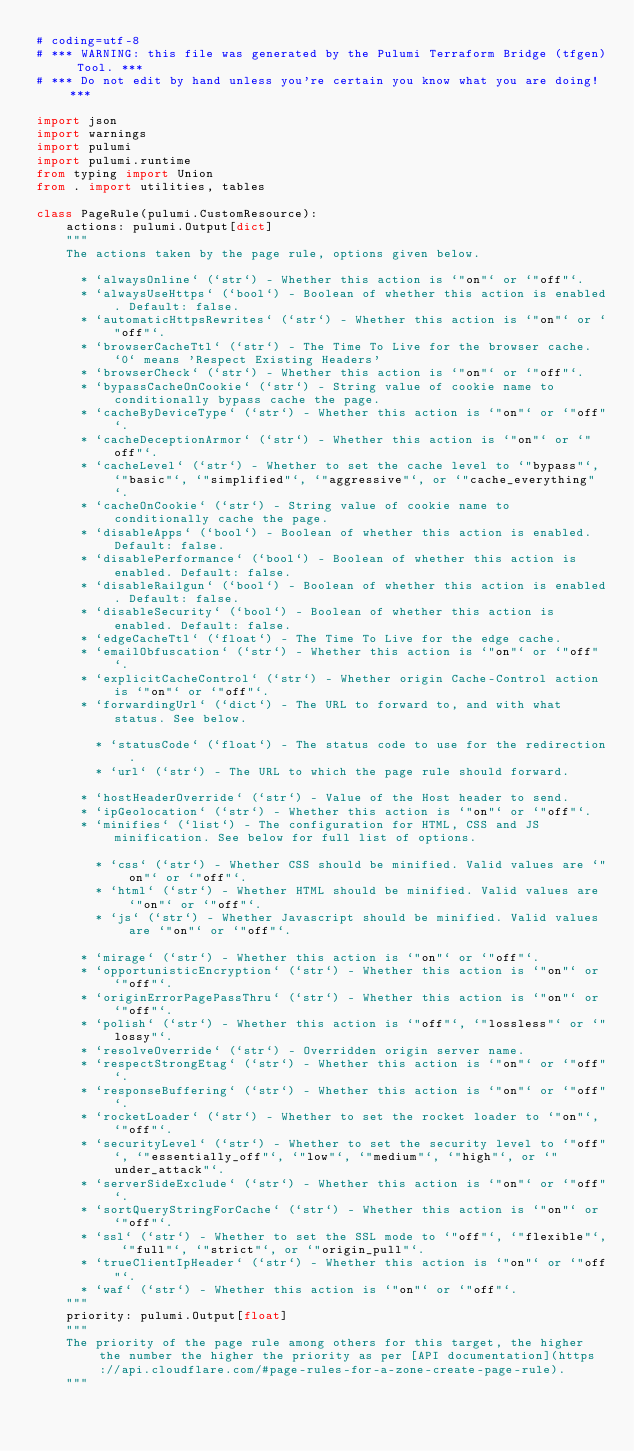<code> <loc_0><loc_0><loc_500><loc_500><_Python_># coding=utf-8
# *** WARNING: this file was generated by the Pulumi Terraform Bridge (tfgen) Tool. ***
# *** Do not edit by hand unless you're certain you know what you are doing! ***

import json
import warnings
import pulumi
import pulumi.runtime
from typing import Union
from . import utilities, tables

class PageRule(pulumi.CustomResource):
    actions: pulumi.Output[dict]
    """
    The actions taken by the page rule, options given below.
    
      * `alwaysOnline` (`str`) - Whether this action is `"on"` or `"off"`.
      * `alwaysUseHttps` (`bool`) - Boolean of whether this action is enabled. Default: false.
      * `automaticHttpsRewrites` (`str`) - Whether this action is `"on"` or `"off"`.
      * `browserCacheTtl` (`str`) - The Time To Live for the browser cache. `0` means 'Respect Existing Headers'
      * `browserCheck` (`str`) - Whether this action is `"on"` or `"off"`.
      * `bypassCacheOnCookie` (`str`) - String value of cookie name to conditionally bypass cache the page.
      * `cacheByDeviceType` (`str`) - Whether this action is `"on"` or `"off"`.
      * `cacheDeceptionArmor` (`str`) - Whether this action is `"on"` or `"off"`.
      * `cacheLevel` (`str`) - Whether to set the cache level to `"bypass"`, `"basic"`, `"simplified"`, `"aggressive"`, or `"cache_everything"`.
      * `cacheOnCookie` (`str`) - String value of cookie name to conditionally cache the page.
      * `disableApps` (`bool`) - Boolean of whether this action is enabled. Default: false.
      * `disablePerformance` (`bool`) - Boolean of whether this action is enabled. Default: false.
      * `disableRailgun` (`bool`) - Boolean of whether this action is enabled. Default: false.
      * `disableSecurity` (`bool`) - Boolean of whether this action is enabled. Default: false.
      * `edgeCacheTtl` (`float`) - The Time To Live for the edge cache.
      * `emailObfuscation` (`str`) - Whether this action is `"on"` or `"off"`.
      * `explicitCacheControl` (`str`) - Whether origin Cache-Control action is `"on"` or `"off"`.
      * `forwardingUrl` (`dict`) - The URL to forward to, and with what status. See below.
    
        * `statusCode` (`float`) - The status code to use for the redirection.
        * `url` (`str`) - The URL to which the page rule should forward.
    
      * `hostHeaderOverride` (`str`) - Value of the Host header to send.
      * `ipGeolocation` (`str`) - Whether this action is `"on"` or `"off"`.
      * `minifies` (`list`) - The configuration for HTML, CSS and JS minification. See below for full list of options.
    
        * `css` (`str`) - Whether CSS should be minified. Valid values are `"on"` or `"off"`.
        * `html` (`str`) - Whether HTML should be minified. Valid values are `"on"` or `"off"`.
        * `js` (`str`) - Whether Javascript should be minified. Valid values are `"on"` or `"off"`.
    
      * `mirage` (`str`) - Whether this action is `"on"` or `"off"`.
      * `opportunisticEncryption` (`str`) - Whether this action is `"on"` or `"off"`.
      * `originErrorPagePassThru` (`str`) - Whether this action is `"on"` or `"off"`.
      * `polish` (`str`) - Whether this action is `"off"`, `"lossless"` or `"lossy"`.
      * `resolveOverride` (`str`) - Overridden origin server name.
      * `respectStrongEtag` (`str`) - Whether this action is `"on"` or `"off"`.
      * `responseBuffering` (`str`) - Whether this action is `"on"` or `"off"`.
      * `rocketLoader` (`str`) - Whether to set the rocket loader to `"on"`, `"off"`.
      * `securityLevel` (`str`) - Whether to set the security level to `"off"`, `"essentially_off"`, `"low"`, `"medium"`, `"high"`, or `"under_attack"`.
      * `serverSideExclude` (`str`) - Whether this action is `"on"` or `"off"`.
      * `sortQueryStringForCache` (`str`) - Whether this action is `"on"` or `"off"`.
      * `ssl` (`str`) - Whether to set the SSL mode to `"off"`, `"flexible"`, `"full"`, `"strict"`, or `"origin_pull"`.
      * `trueClientIpHeader` (`str`) - Whether this action is `"on"` or `"off"`.
      * `waf` (`str`) - Whether this action is `"on"` or `"off"`.
    """
    priority: pulumi.Output[float]
    """
    The priority of the page rule among others for this target, the higher the number the higher the priority as per [API documentation](https://api.cloudflare.com/#page-rules-for-a-zone-create-page-rule).
    """</code> 